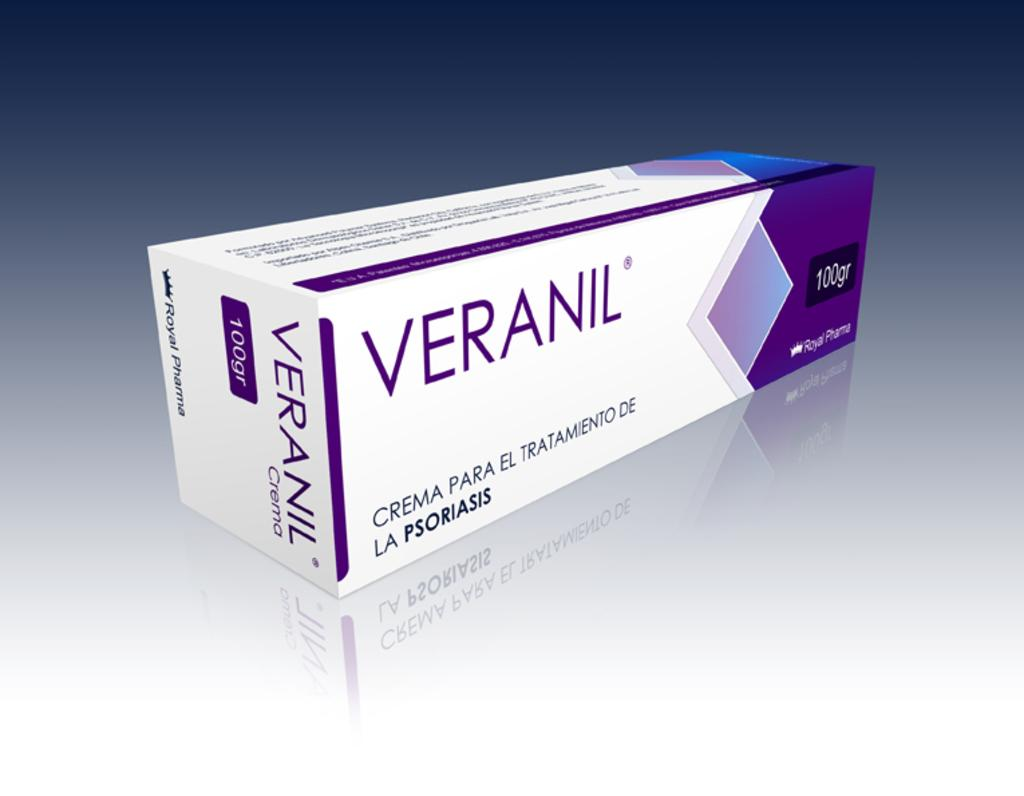Provide a one-sentence caption for the provided image. A box of Veranil from Royal Pharma has 100 grams. 